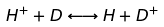Convert formula to latex. <formula><loc_0><loc_0><loc_500><loc_500>H ^ { + } + D \longleftrightarrow H + D ^ { + }</formula> 